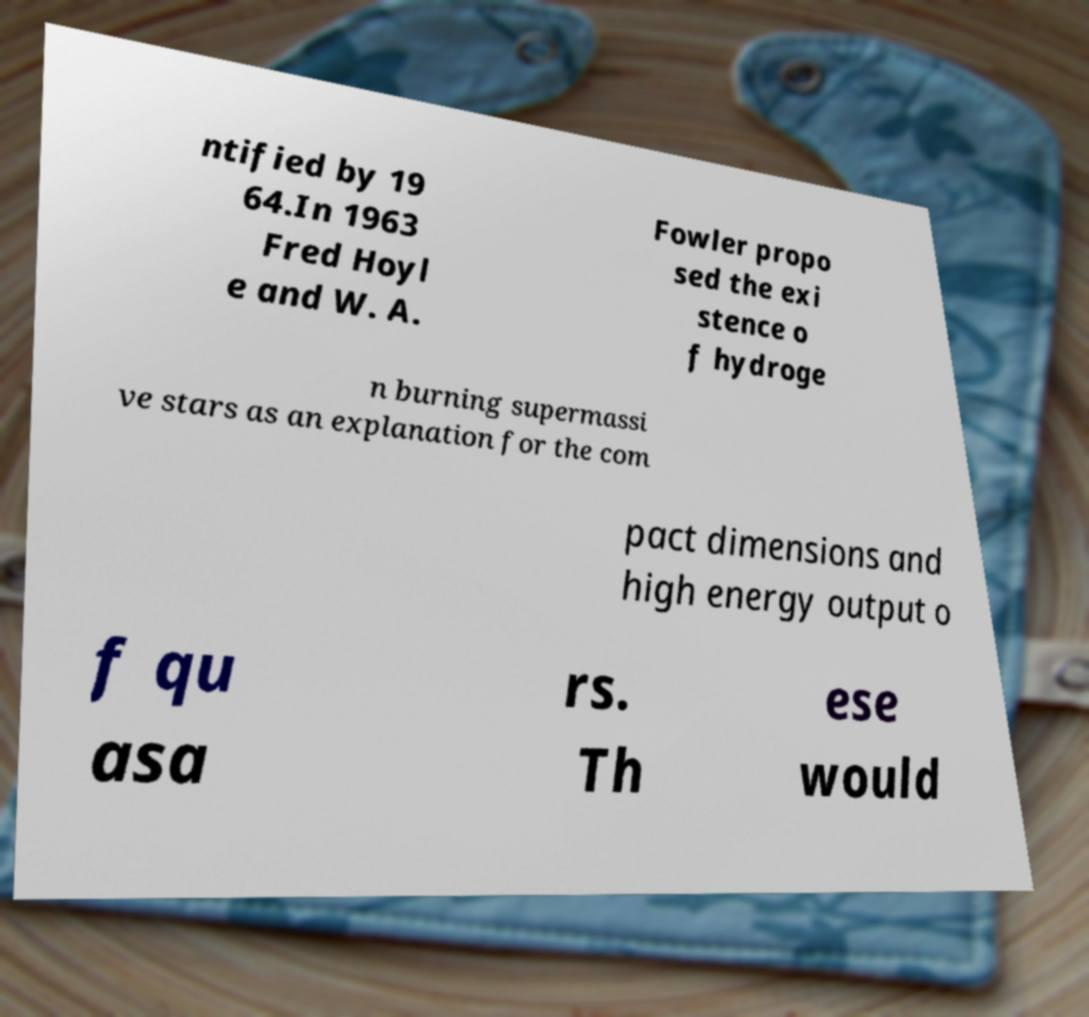I need the written content from this picture converted into text. Can you do that? ntified by 19 64.In 1963 Fred Hoyl e and W. A. Fowler propo sed the exi stence o f hydroge n burning supermassi ve stars as an explanation for the com pact dimensions and high energy output o f qu asa rs. Th ese would 